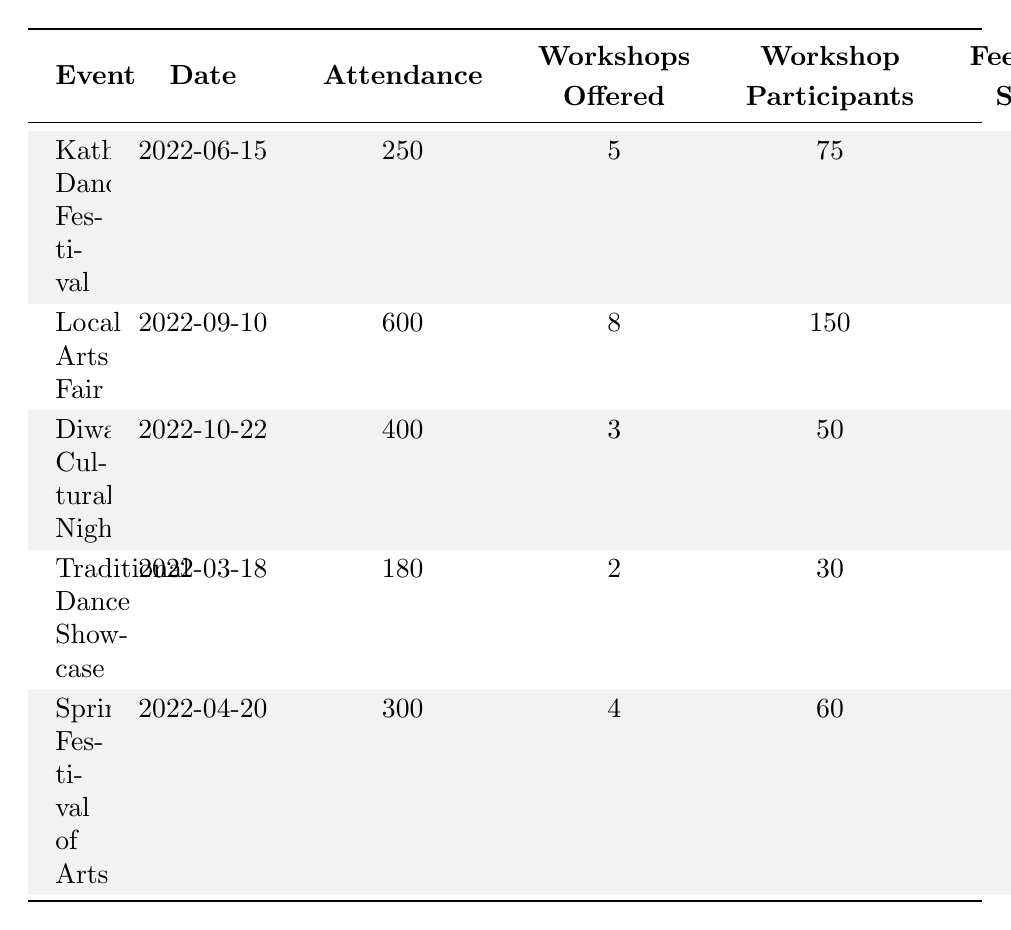What was the attendance at the Kathak Dance Festival? The attendance figure for the Kathak Dance Festival is directly listed in the table, which shows 250 attendees.
Answer: 250 How many workshops were offered at the Local Arts Fair? The table specifies that the Local Arts Fair had 8 workshops offered.
Answer: 8 What is the community feedback score for the Diwali Cultural Night? The community feedback score is shown in the table, and for the Diwali Cultural Night, it is 9.5.
Answer: 9.5 Which event had the highest attendance? By comparing the attendance figures in the table, the Local Arts Fair had the highest attendance at 600.
Answer: Local Arts Fair What is the average attendance across all events listed in the table? To find the average attendance: (250 + 600 + 400 + 180 + 300) = 1730. Divide by 5 events gives 1730/5 = 346.
Answer: 346 Did the Traditional Dance Showcase have more participants in workshops than the Kathak Dance Festival? The table lists 30 participants for the Traditional Dance Showcase and 75 participants for the Kathak Dance Festival. Since 30 is less than 75, the answer is no.
Answer: No Which event had the lowest community feedback score? By reviewing the feedback scores in the table, the Traditional Dance Showcase has the lowest score of 8.9.
Answer: Traditional Dance Showcase What is the total number of participants in workshops across all events? Summing the participants from all events: 75 (Kathak) + 150 (Local Arts Fair) + 50 (Diwali) + 30 (Traditional) + 60 (Spring) = 365.
Answer: 365 Was the number of workshops offered at the Spring Festival of Arts more than the number of workshops at the Diwali Cultural Night? The Spring Festival of Arts had 4 workshops while the Diwali Cultural Night had 3 workshops. Since 4 is greater than 3, the answer is yes.
Answer: Yes What is the difference in attendance between the Local Arts Fair and the Traditional Dance Showcase? The difference in attendance is calculated by subtracting: 600 (Local Arts Fair) - 180 (Traditional) = 420.
Answer: 420 